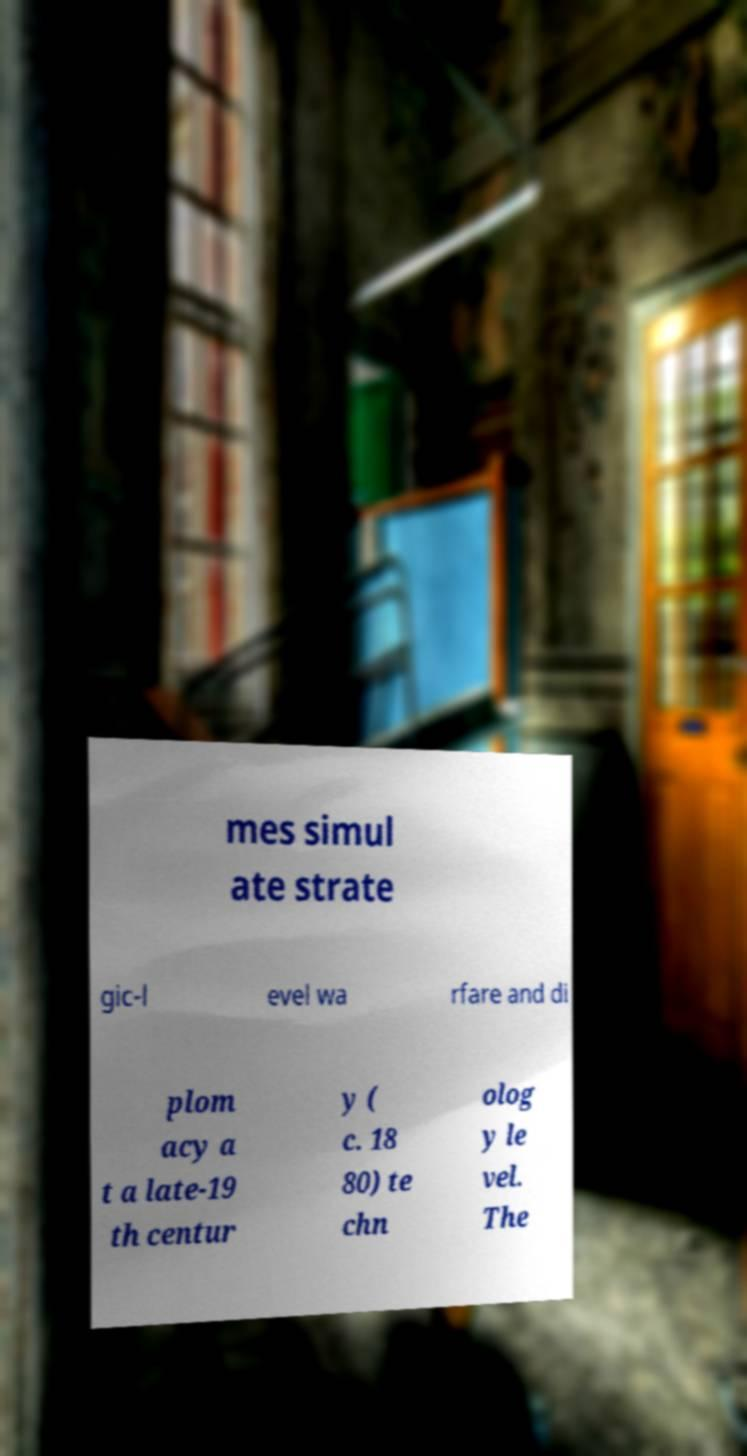What messages or text are displayed in this image? I need them in a readable, typed format. mes simul ate strate gic-l evel wa rfare and di plom acy a t a late-19 th centur y ( c. 18 80) te chn olog y le vel. The 